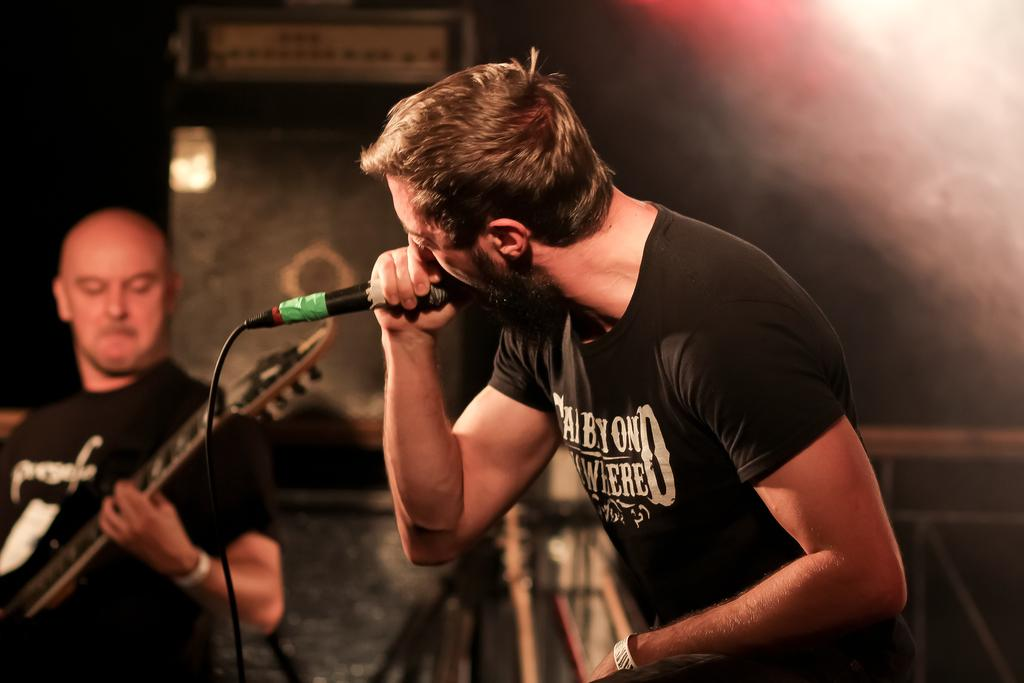What is the man in the image doing? The man in the image is singing. What object is the man holding while singing? The man is holding a microphone. What instrument is being played by another person in the image? There is a person playing a guitar in the image. Where is the person playing the guitar located in relation to the man singing? The person playing the guitar is beside the man singing. Can you see any yaks in the image? No, there are no yaks present in the image. How many geese are visible in the image? There are no geese present in the image. 